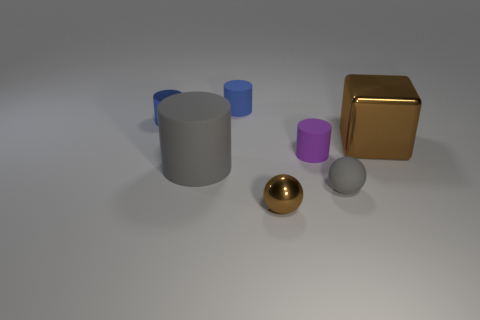There is a cylinder that is the same size as the metal block; what is its color?
Your answer should be very brief. Gray. How many yellow things are small cylinders or balls?
Keep it short and to the point. 0. Are there more tiny purple matte things than big blue rubber cylinders?
Provide a succinct answer. Yes. There is a brown object behind the small brown thing; is its size the same as the gray rubber sphere on the right side of the blue metal thing?
Keep it short and to the point. No. What color is the small cylinder left of the gray matte object that is to the left of the tiny sphere that is left of the tiny gray sphere?
Offer a terse response. Blue. Is there a big thing that has the same shape as the tiny blue metal thing?
Give a very brief answer. Yes. Are there more things that are on the right side of the small metallic sphere than metal spheres?
Provide a succinct answer. Yes. How many rubber objects are either tiny red objects or purple cylinders?
Offer a terse response. 1. What is the size of the object that is both to the right of the large gray matte cylinder and behind the large brown shiny block?
Ensure brevity in your answer.  Small. There is a tiny blue object on the right side of the shiny cylinder; is there a brown metal thing that is behind it?
Offer a terse response. No. 